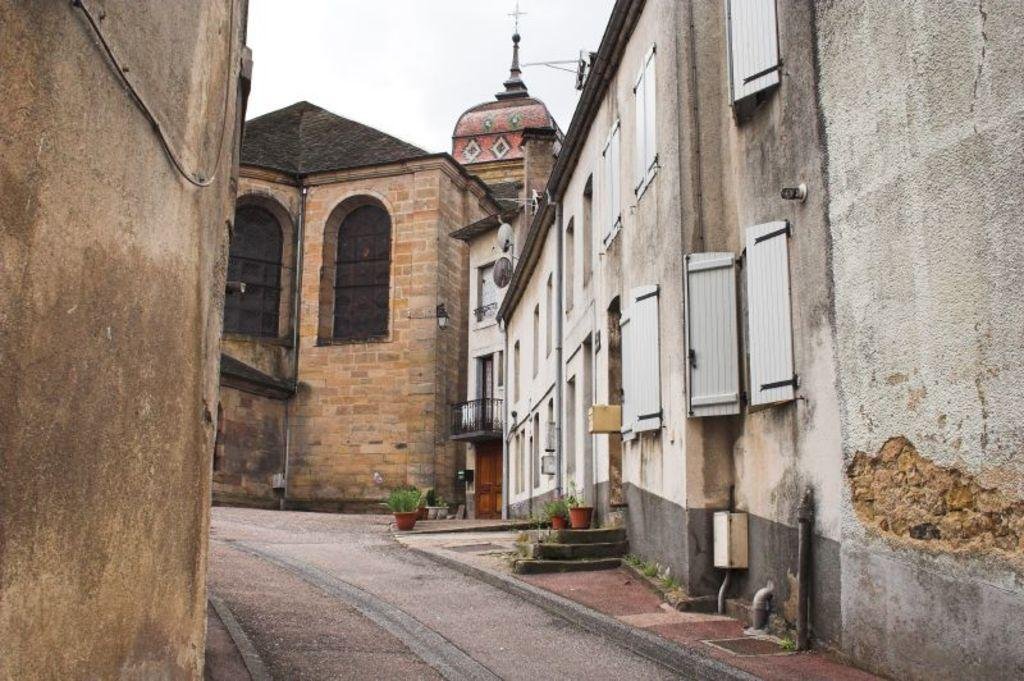What type of structures can be seen in the image? There are buildings in the image. What is visible at the top of the image? The sky is visible at the top of the image. What is located at the bottom of the image? There is a road and a pavement at the bottom of the image. What type of vegetation can be seen at the bottom of the image? Potted plants are present at the bottom of the image. What is the man's reaction to the surprise blood donation event in the image? There is no man, surprise, or blood donation event present in the image. 